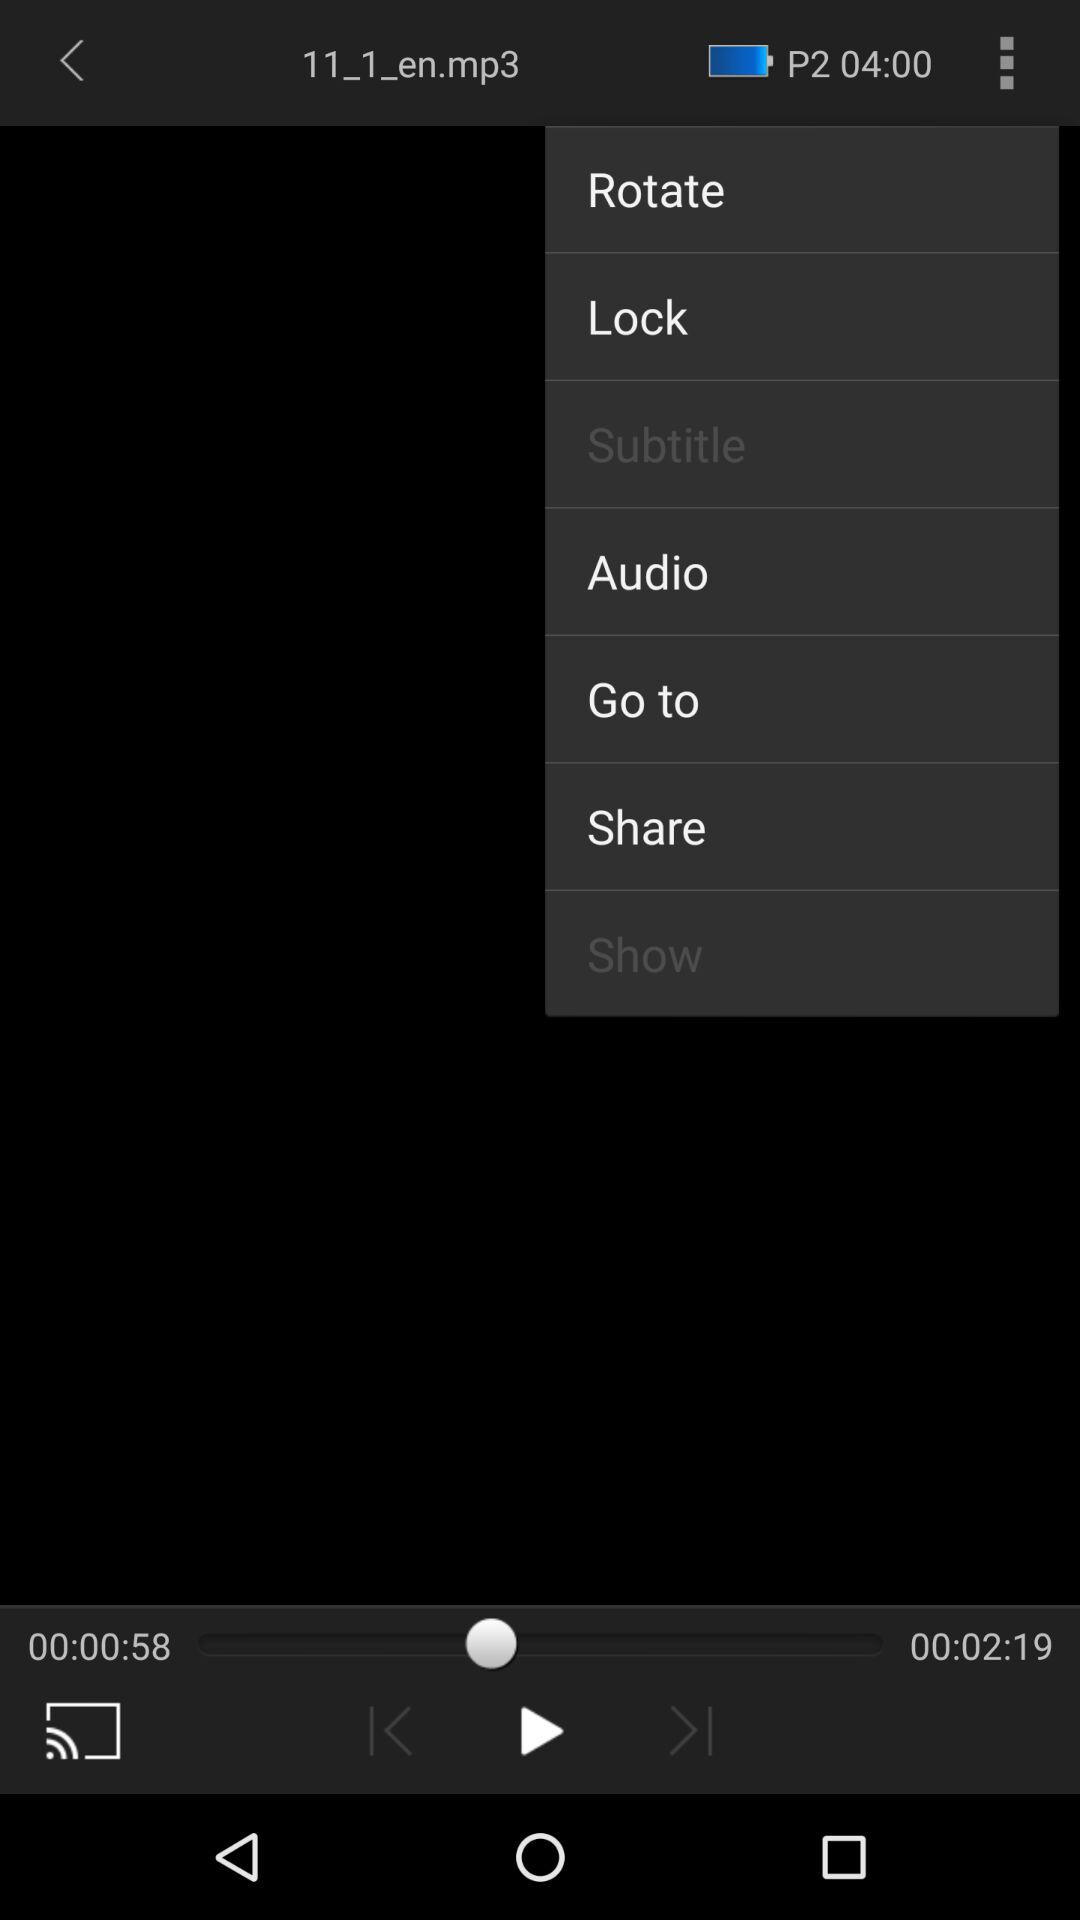How long is the video?
Answer the question using a single word or phrase. 00:02:19 